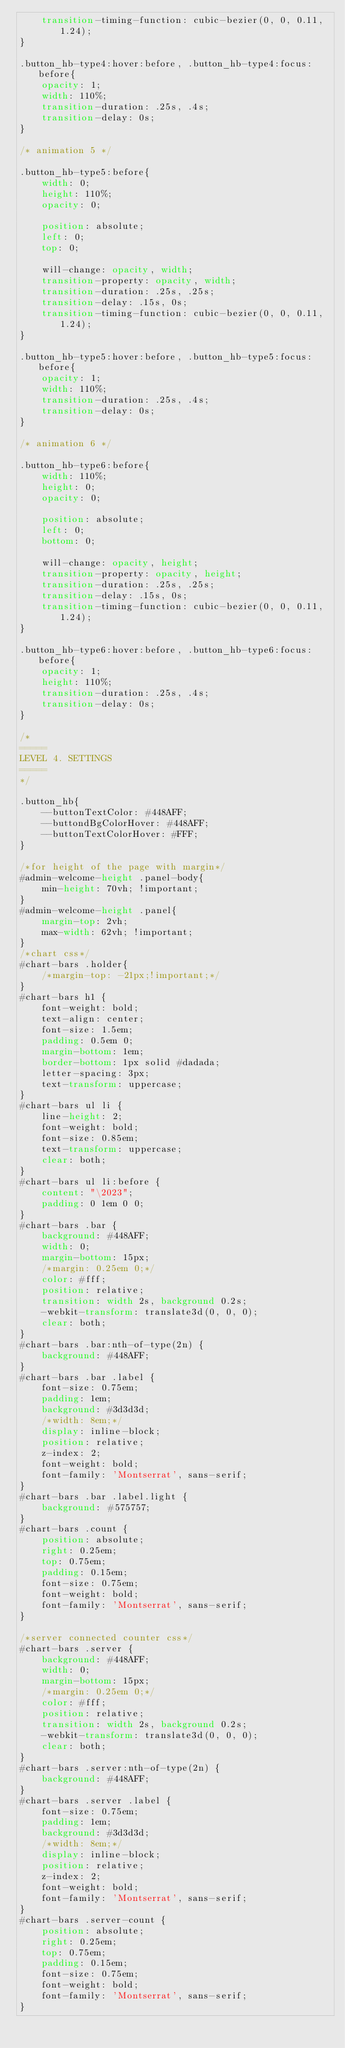<code> <loc_0><loc_0><loc_500><loc_500><_CSS_>    transition-timing-function: cubic-bezier(0, 0, 0.11, 1.24);
}

.button_hb-type4:hover:before, .button_hb-type4:focus:before{
    opacity: 1;
    width: 110%;
    transition-duration: .25s, .4s;
    transition-delay: 0s;
}

/* animation 5 */

.button_hb-type5:before{
    width: 0;
    height: 110%;
    opacity: 0;

    position: absolute;
    left: 0;
    top: 0;

    will-change: opacity, width;
    transition-property: opacity, width;
    transition-duration: .25s, .25s;
    transition-delay: .15s, 0s;
    transition-timing-function: cubic-bezier(0, 0, 0.11, 1.24);
}

.button_hb-type5:hover:before, .button_hb-type5:focus:before{
    opacity: 1;
    width: 110%;
    transition-duration: .25s, .4s;
    transition-delay: 0s;
}

/* animation 6 */

.button_hb-type6:before{
    width: 110%;
    height: 0;
    opacity: 0;

    position: absolute;
    left: 0;
    bottom: 0;

    will-change: opacity, height;
    transition-property: opacity, height;
    transition-duration: .25s, .25s;
    transition-delay: .15s, 0s;
    transition-timing-function: cubic-bezier(0, 0, 0.11, 1.24);
}

.button_hb-type6:hover:before, .button_hb-type6:focus:before{
    opacity: 1;
    height: 110%;
    transition-duration: .25s, .4s;
    transition-delay: 0s;
}

/*
=====
LEVEL 4. SETTINGS
=====
*/

.button_hb{
    --buttonTextColor: #448AFF;
    --buttondBgColorHover: #448AFF;
    --buttonTextColorHover: #FFF;
}

/*for height of the page with margin*/
#admin-welcome-height .panel-body{
    min-height: 70vh; !important;
}
#admin-welcome-height .panel{
    margin-top: 2vh;
    max-width: 62vh; !important;
}
/*chart css*/
#chart-bars .holder{
    /*margin-top: -21px;!important;*/
}
#chart-bars h1 {
    font-weight: bold;
    text-align: center;
    font-size: 1.5em;
    padding: 0.5em 0;
    margin-bottom: 1em;
    border-bottom: 1px solid #dadada;
    letter-spacing: 3px;
    text-transform: uppercase;
}
#chart-bars ul li {
    line-height: 2;
    font-weight: bold;
    font-size: 0.85em;
    text-transform: uppercase;
    clear: both;
}
#chart-bars ul li:before {
    content: "\2023";
    padding: 0 1em 0 0;
}
#chart-bars .bar {
    background: #448AFF;
    width: 0;
    margin-bottom: 15px;
    /*margin: 0.25em 0;*/
    color: #fff;
    position: relative;
    transition: width 2s, background 0.2s;
    -webkit-transform: translate3d(0, 0, 0);
    clear: both;
}
#chart-bars .bar:nth-of-type(2n) {
    background: #448AFF;
}
#chart-bars .bar .label {
    font-size: 0.75em;
    padding: 1em;
    background: #3d3d3d;
    /*width: 8em;*/
    display: inline-block;
    position: relative;
    z-index: 2;
    font-weight: bold;
    font-family: 'Montserrat', sans-serif;
}
#chart-bars .bar .label.light {
    background: #575757;
}
#chart-bars .count {
    position: absolute;
    right: 0.25em;
    top: 0.75em;
    padding: 0.15em;
    font-size: 0.75em;
    font-weight: bold;
    font-family: 'Montserrat', sans-serif;
}

/*server connected counter css*/
#chart-bars .server {
    background: #448AFF;
    width: 0;
    margin-bottom: 15px;
    /*margin: 0.25em 0;*/
    color: #fff;
    position: relative;
    transition: width 2s, background 0.2s;
    -webkit-transform: translate3d(0, 0, 0);
    clear: both;
}
#chart-bars .server:nth-of-type(2n) {
    background: #448AFF;
}
#chart-bars .server .label {
    font-size: 0.75em;
    padding: 1em;
    background: #3d3d3d;
    /*width: 8em;*/
    display: inline-block;
    position: relative;
    z-index: 2;
    font-weight: bold;
    font-family: 'Montserrat', sans-serif;
}
#chart-bars .server-count {
    position: absolute;
    right: 0.25em;
    top: 0.75em;
    padding: 0.15em;
    font-size: 0.75em;
    font-weight: bold;
    font-family: 'Montserrat', sans-serif;
}</code> 